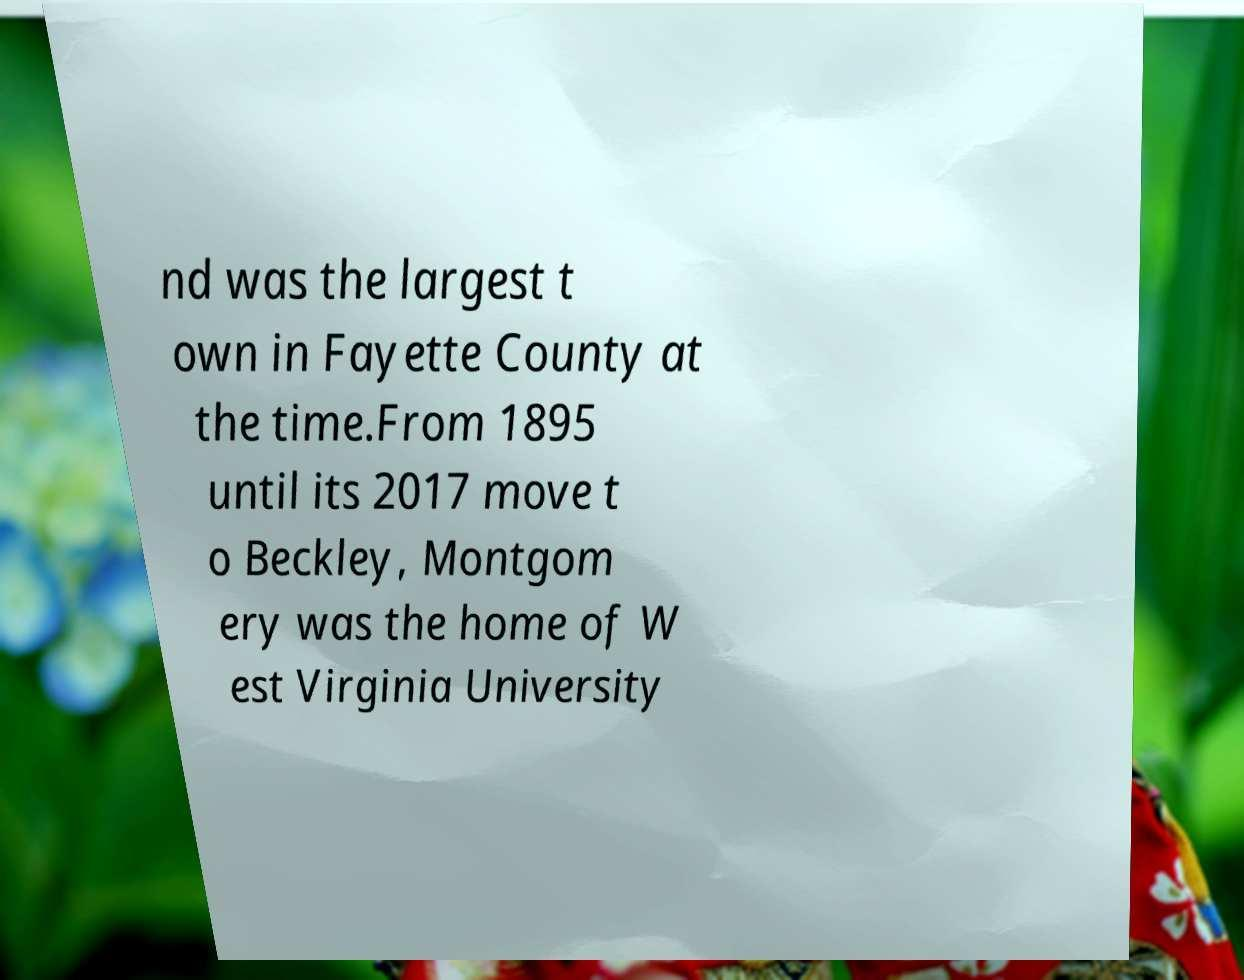What messages or text are displayed in this image? I need them in a readable, typed format. nd was the largest t own in Fayette County at the time.From 1895 until its 2017 move t o Beckley, Montgom ery was the home of W est Virginia University 